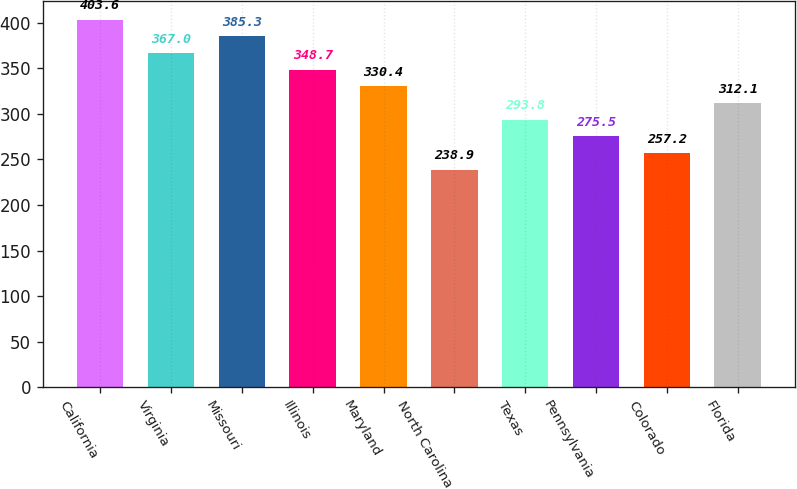Convert chart to OTSL. <chart><loc_0><loc_0><loc_500><loc_500><bar_chart><fcel>California<fcel>Virginia<fcel>Missouri<fcel>Illinois<fcel>Maryland<fcel>North Carolina<fcel>Texas<fcel>Pennsylvania<fcel>Colorado<fcel>Florida<nl><fcel>403.6<fcel>367<fcel>385.3<fcel>348.7<fcel>330.4<fcel>238.9<fcel>293.8<fcel>275.5<fcel>257.2<fcel>312.1<nl></chart> 